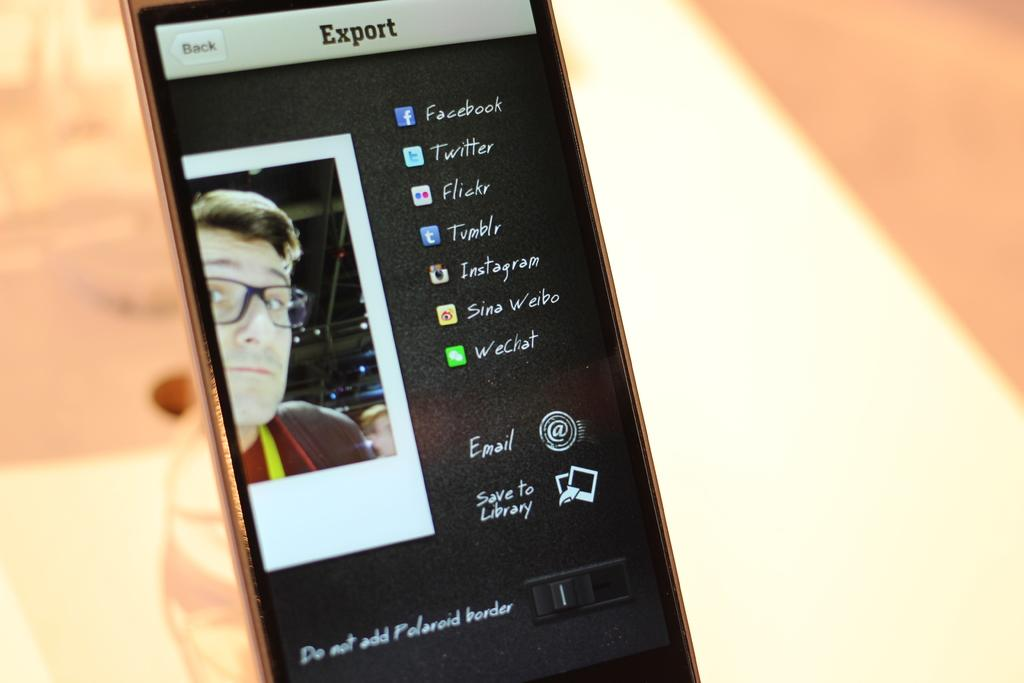Provide a one-sentence caption for the provided image. Export displaying the picture of a guy and the links to his social media. 